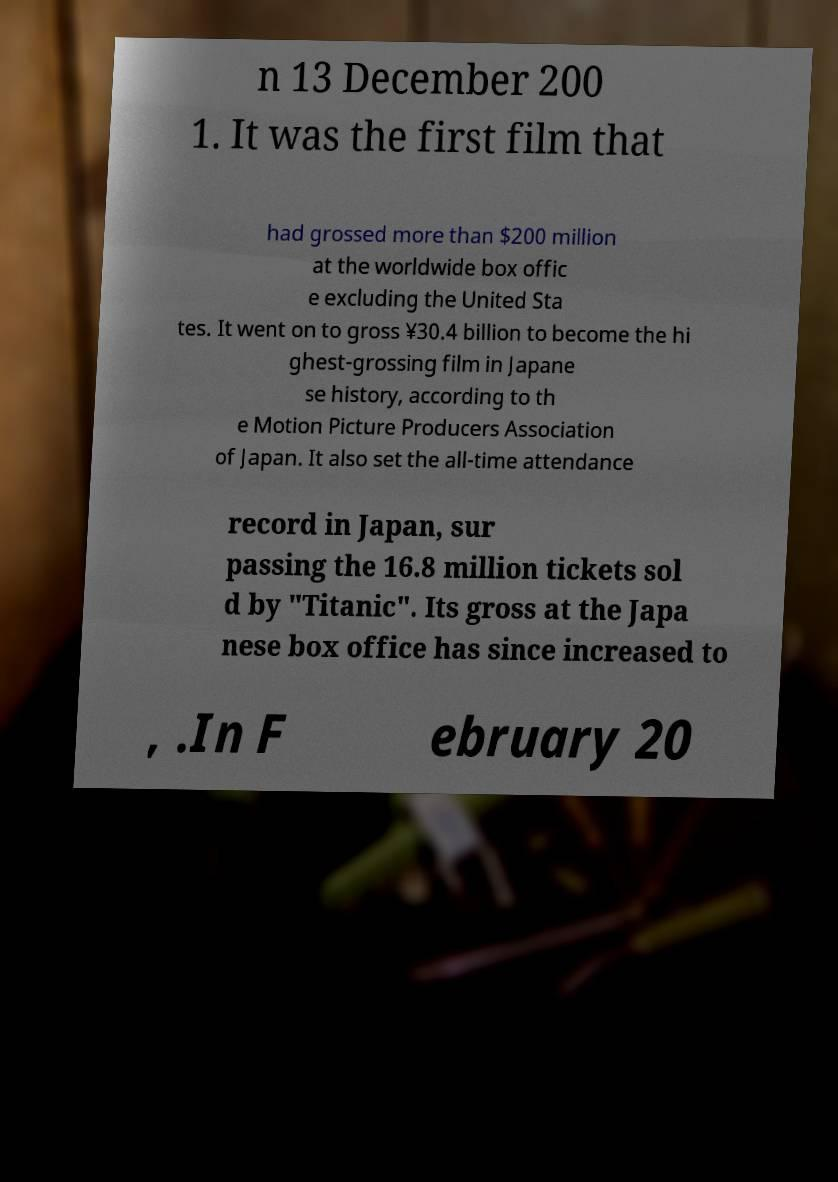Can you read and provide the text displayed in the image?This photo seems to have some interesting text. Can you extract and type it out for me? n 13 December 200 1. It was the first film that had grossed more than $200 million at the worldwide box offic e excluding the United Sta tes. It went on to gross ¥30.4 billion to become the hi ghest-grossing film in Japane se history, according to th e Motion Picture Producers Association of Japan. It also set the all-time attendance record in Japan, sur passing the 16.8 million tickets sol d by "Titanic". Its gross at the Japa nese box office has since increased to , .In F ebruary 20 